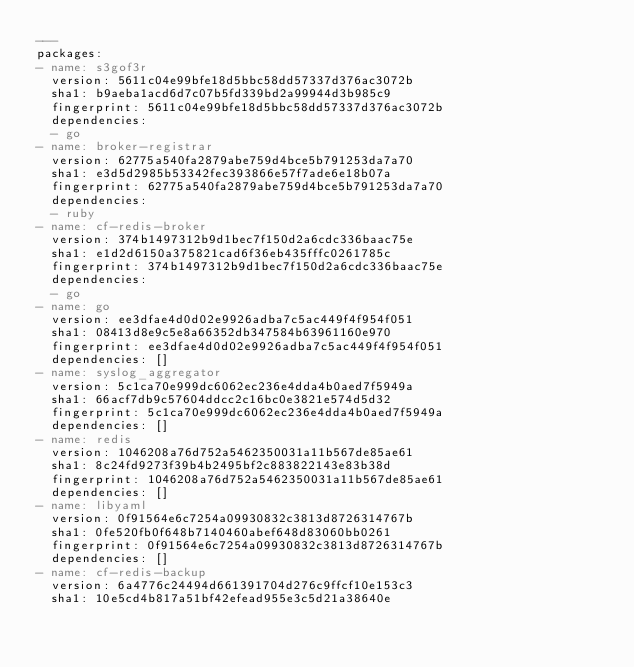<code> <loc_0><loc_0><loc_500><loc_500><_YAML_>---
packages:
- name: s3gof3r
  version: 5611c04e99bfe18d5bbc58dd57337d376ac3072b
  sha1: b9aeba1acd6d7c07b5fd339bd2a99944d3b985c9
  fingerprint: 5611c04e99bfe18d5bbc58dd57337d376ac3072b
  dependencies:
  - go
- name: broker-registrar
  version: 62775a540fa2879abe759d4bce5b791253da7a70
  sha1: e3d5d2985b53342fec393866e57f7ade6e18b07a
  fingerprint: 62775a540fa2879abe759d4bce5b791253da7a70
  dependencies:
  - ruby
- name: cf-redis-broker
  version: 374b1497312b9d1bec7f150d2a6cdc336baac75e
  sha1: e1d2d6150a375821cad6f36eb435fffc0261785c
  fingerprint: 374b1497312b9d1bec7f150d2a6cdc336baac75e
  dependencies:
  - go
- name: go
  version: ee3dfae4d0d02e9926adba7c5ac449f4f954f051
  sha1: 08413d8e9c5e8a66352db347584b63961160e970
  fingerprint: ee3dfae4d0d02e9926adba7c5ac449f4f954f051
  dependencies: []
- name: syslog_aggregator
  version: 5c1ca70e999dc6062ec236e4dda4b0aed7f5949a
  sha1: 66acf7db9c57604ddcc2c16bc0e3821e574d5d32
  fingerprint: 5c1ca70e999dc6062ec236e4dda4b0aed7f5949a
  dependencies: []
- name: redis
  version: 1046208a76d752a5462350031a11b567de85ae61
  sha1: 8c24fd9273f39b4b2495bf2c883822143e83b38d
  fingerprint: 1046208a76d752a5462350031a11b567de85ae61
  dependencies: []
- name: libyaml
  version: 0f91564e6c7254a09930832c3813d8726314767b
  sha1: 0fe520fb0f648b7140460abef648d83060bb0261
  fingerprint: 0f91564e6c7254a09930832c3813d8726314767b
  dependencies: []
- name: cf-redis-backup
  version: 6a4776c24494d661391704d276c9ffcf10e153c3
  sha1: 10e5cd4b817a51bf42efead955e3c5d21a38640e</code> 